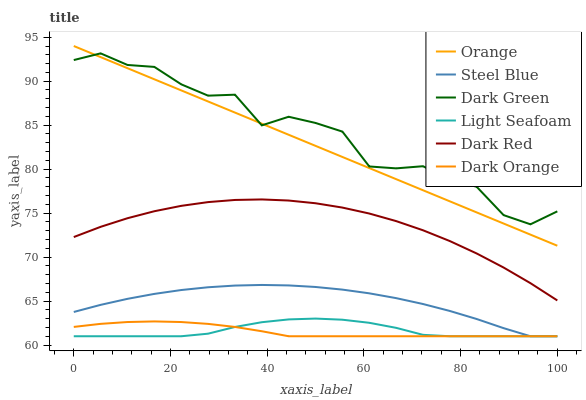Does Dark Red have the minimum area under the curve?
Answer yes or no. No. Does Dark Red have the maximum area under the curve?
Answer yes or no. No. Is Dark Red the smoothest?
Answer yes or no. No. Is Dark Red the roughest?
Answer yes or no. No. Does Dark Red have the lowest value?
Answer yes or no. No. Does Dark Red have the highest value?
Answer yes or no. No. Is Light Seafoam less than Dark Red?
Answer yes or no. Yes. Is Dark Red greater than Steel Blue?
Answer yes or no. Yes. Does Light Seafoam intersect Dark Red?
Answer yes or no. No. 